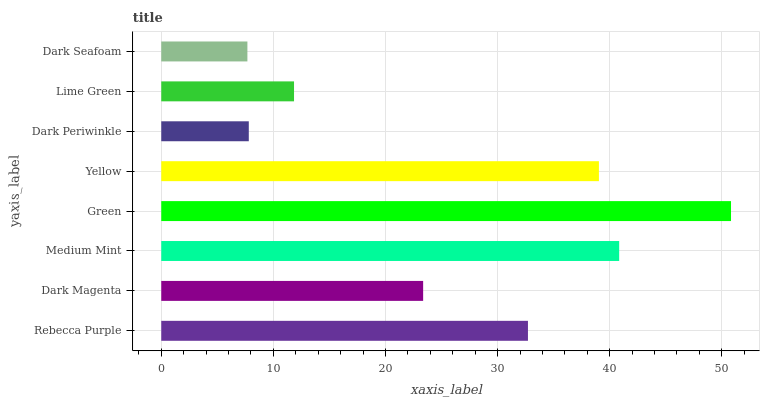Is Dark Seafoam the minimum?
Answer yes or no. Yes. Is Green the maximum?
Answer yes or no. Yes. Is Dark Magenta the minimum?
Answer yes or no. No. Is Dark Magenta the maximum?
Answer yes or no. No. Is Rebecca Purple greater than Dark Magenta?
Answer yes or no. Yes. Is Dark Magenta less than Rebecca Purple?
Answer yes or no. Yes. Is Dark Magenta greater than Rebecca Purple?
Answer yes or no. No. Is Rebecca Purple less than Dark Magenta?
Answer yes or no. No. Is Rebecca Purple the high median?
Answer yes or no. Yes. Is Dark Magenta the low median?
Answer yes or no. Yes. Is Dark Magenta the high median?
Answer yes or no. No. Is Rebecca Purple the low median?
Answer yes or no. No. 